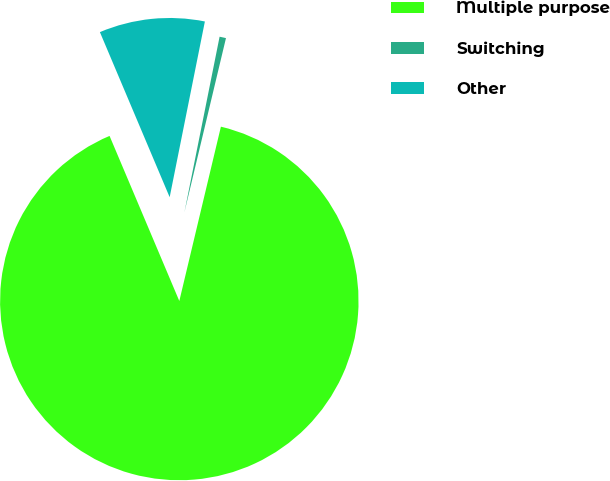Convert chart to OTSL. <chart><loc_0><loc_0><loc_500><loc_500><pie_chart><fcel>Multiple purpose<fcel>Switching<fcel>Other<nl><fcel>89.9%<fcel>0.58%<fcel>9.51%<nl></chart> 